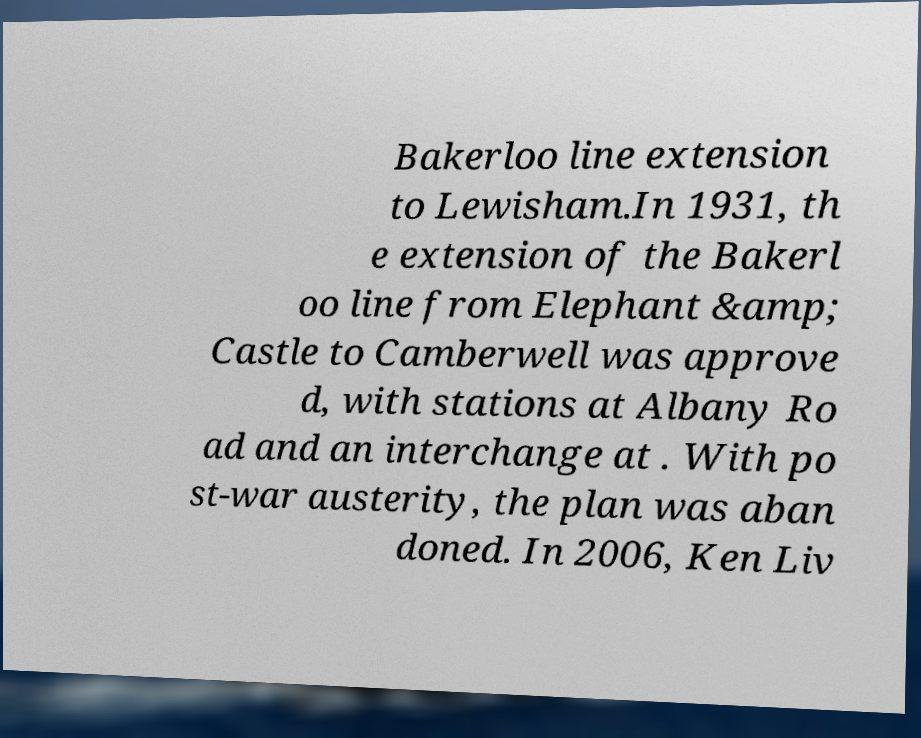Can you read and provide the text displayed in the image?This photo seems to have some interesting text. Can you extract and type it out for me? Bakerloo line extension to Lewisham.In 1931, th e extension of the Bakerl oo line from Elephant &amp; Castle to Camberwell was approve d, with stations at Albany Ro ad and an interchange at . With po st-war austerity, the plan was aban doned. In 2006, Ken Liv 